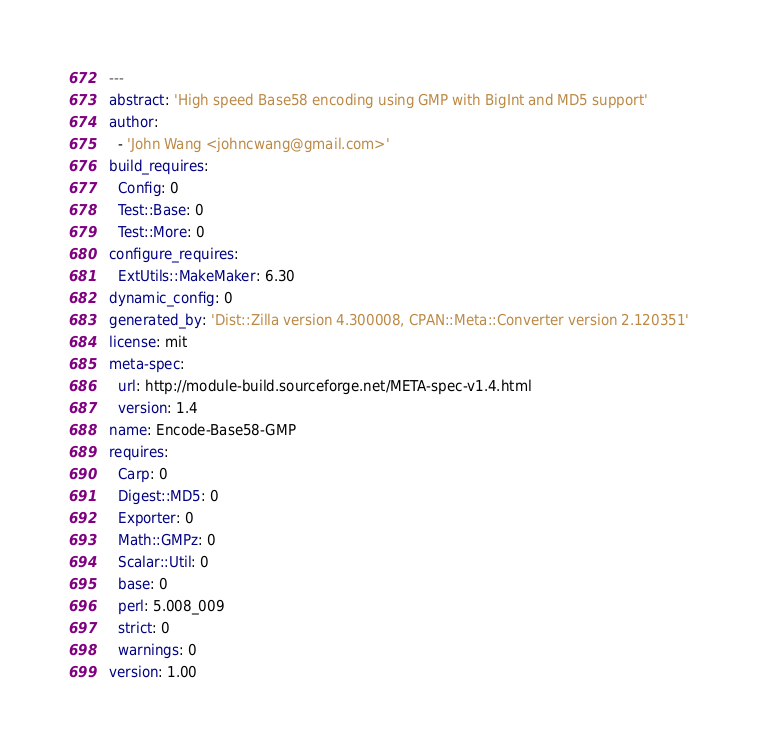Convert code to text. <code><loc_0><loc_0><loc_500><loc_500><_YAML_>---
abstract: 'High speed Base58 encoding using GMP with BigInt and MD5 support'
author:
  - 'John Wang <johncwang@gmail.com>'
build_requires:
  Config: 0
  Test::Base: 0
  Test::More: 0
configure_requires:
  ExtUtils::MakeMaker: 6.30
dynamic_config: 0
generated_by: 'Dist::Zilla version 4.300008, CPAN::Meta::Converter version 2.120351'
license: mit
meta-spec:
  url: http://module-build.sourceforge.net/META-spec-v1.4.html
  version: 1.4
name: Encode-Base58-GMP
requires:
  Carp: 0
  Digest::MD5: 0
  Exporter: 0
  Math::GMPz: 0
  Scalar::Util: 0
  base: 0
  perl: 5.008_009
  strict: 0
  warnings: 0
version: 1.00
</code> 